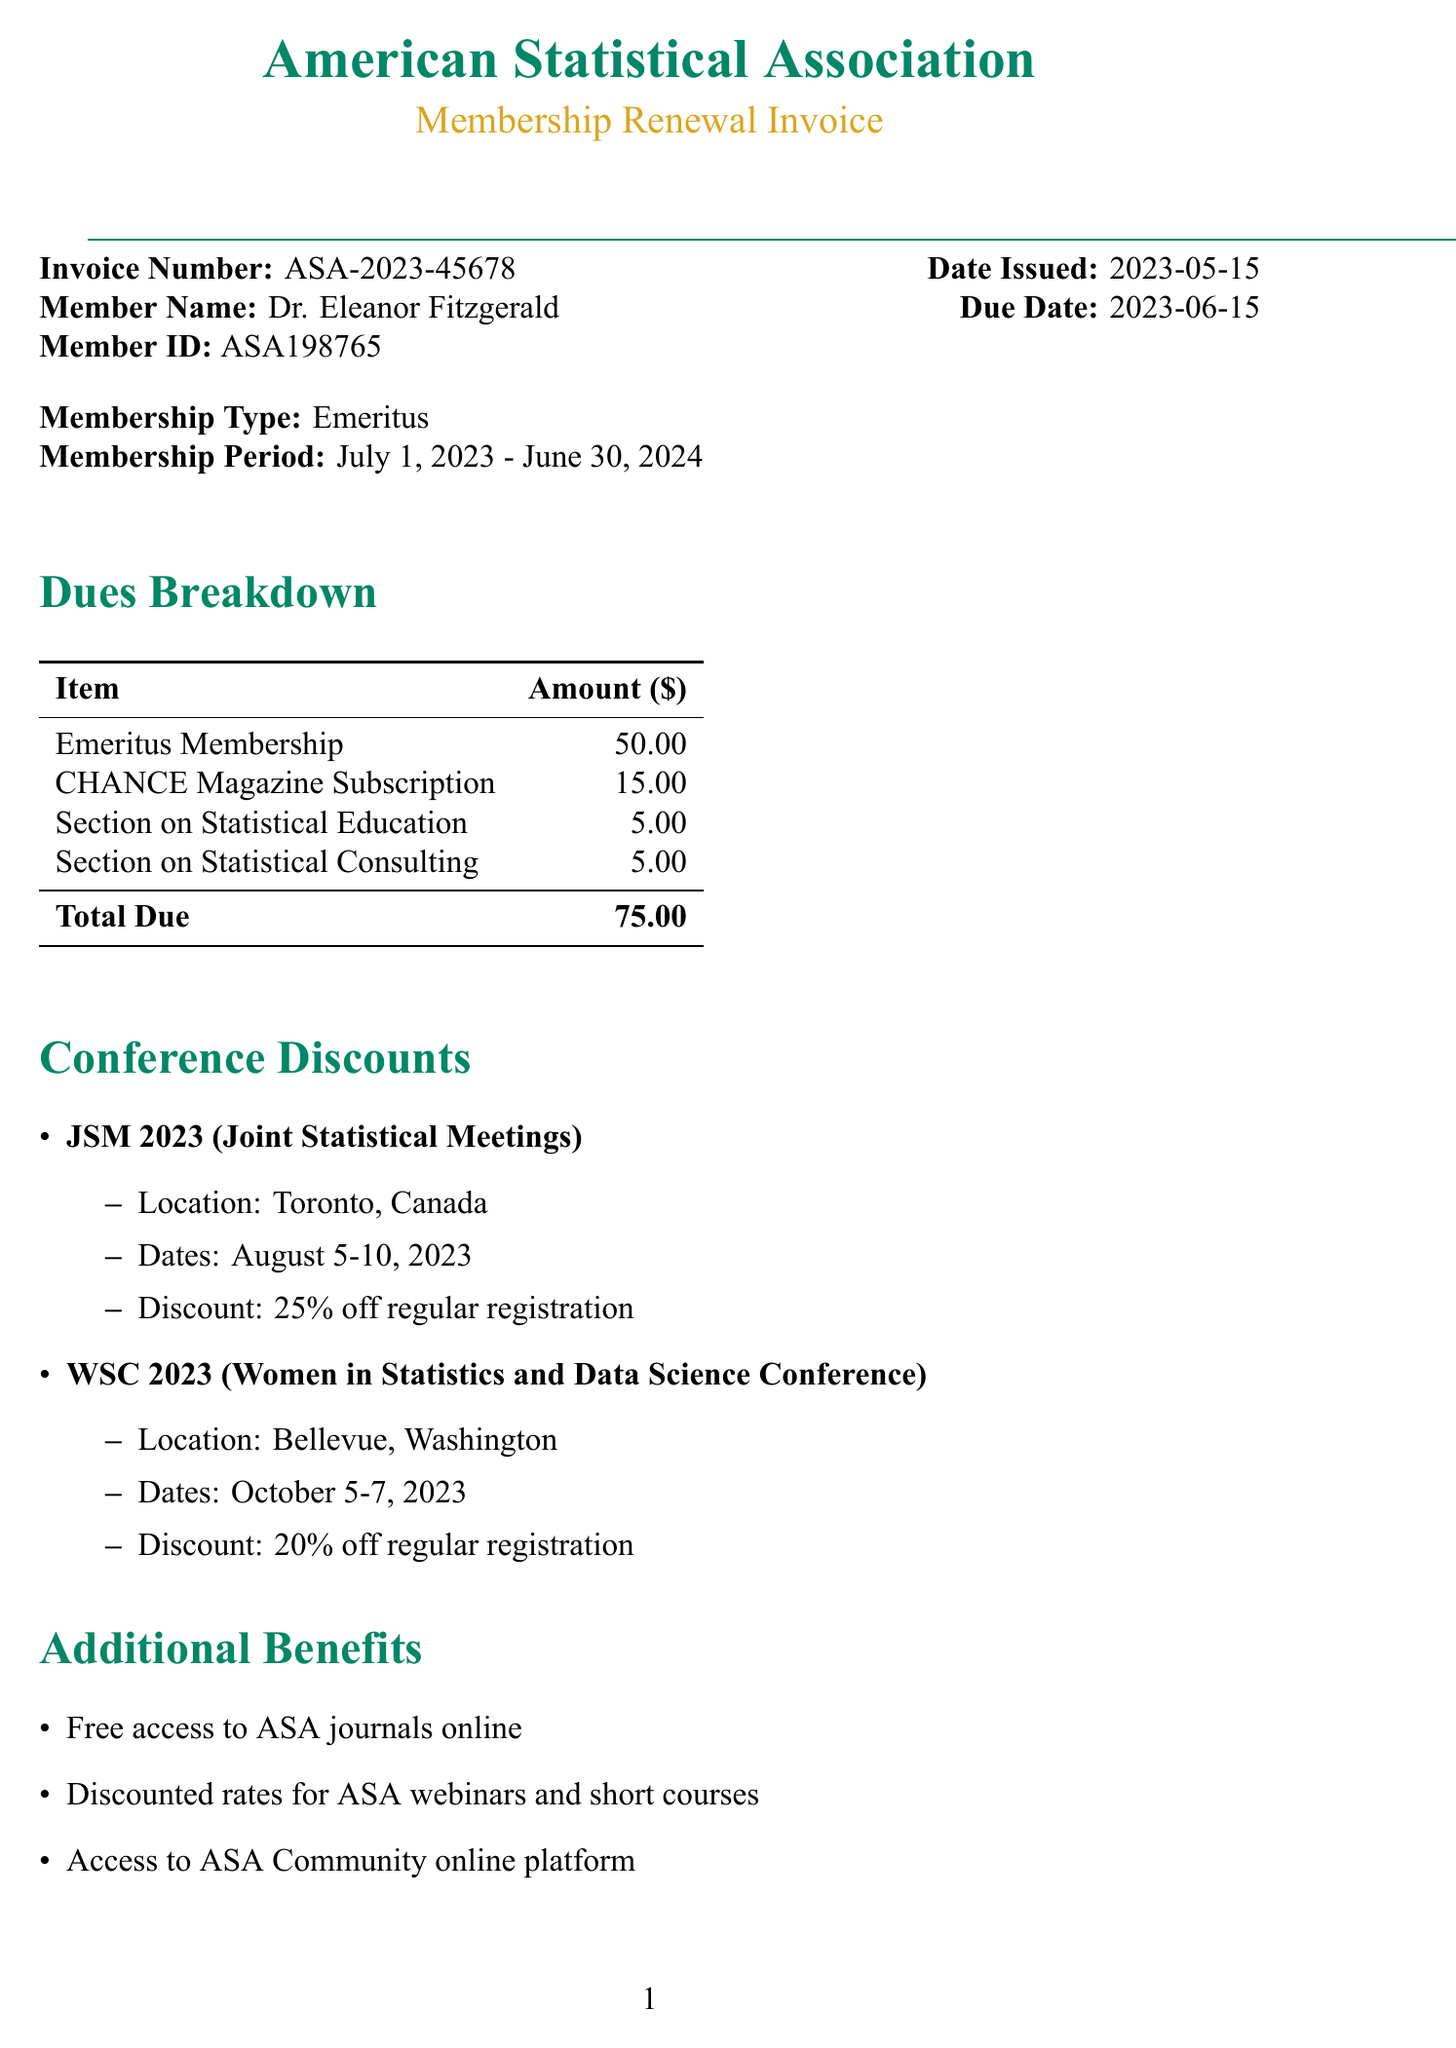What is the invoice number? The invoice number is specified in the document under the invoice details.
Answer: ASA-2023-45678 What is the member's name? The member's name is provided in the invoice details section.
Answer: Dr. Eleanor Fitzgerald What is the total amount due? The total amount due is calculated from the dues breakdown section.
Answer: 75.00 What type of membership is being renewed? The membership type is explicitly stated in the document.
Answer: Emeritus What is the discount for JSM 2023? The discount for JSM 2023 is listed under the conference discounts.
Answer: 25% off regular registration What is the due date for the invoice? The due date is provided in the invoice details.
Answer: 2023-06-15 What method can be used to pay by check? The payment options detail the method for check payments.
Answer: Payable to 'American Statistical Association' What additional benefit provides access to journals? The additional benefits section lists access to journals as a benefit.
Answer: Free access to ASA journals online Where is the JSM 2023 conference located? The location of the JSM 2023 conference is found in the conference discounts section.
Answer: Toronto, Canada 